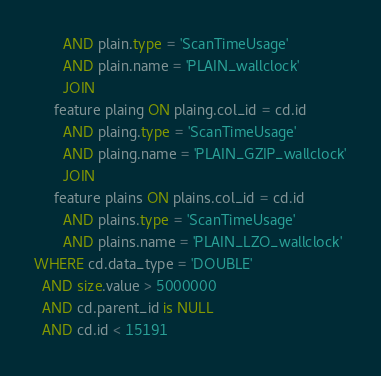<code> <loc_0><loc_0><loc_500><loc_500><_SQL_>       AND plain.type = 'ScanTimeUsage'
       AND plain.name = 'PLAIN_wallclock'
       JOIN
     feature plaing ON plaing.col_id = cd.id
       AND plaing.type = 'ScanTimeUsage'
       AND plaing.name = 'PLAIN_GZIP_wallclock'
       JOIN
     feature plains ON plains.col_id = cd.id
       AND plains.type = 'ScanTimeUsage'
       AND plains.name = 'PLAIN_LZO_wallclock'
WHERE cd.data_type = 'DOUBLE'
  AND size.value > 5000000
  AND cd.parent_id is NULL
  AND cd.id < 15191</code> 